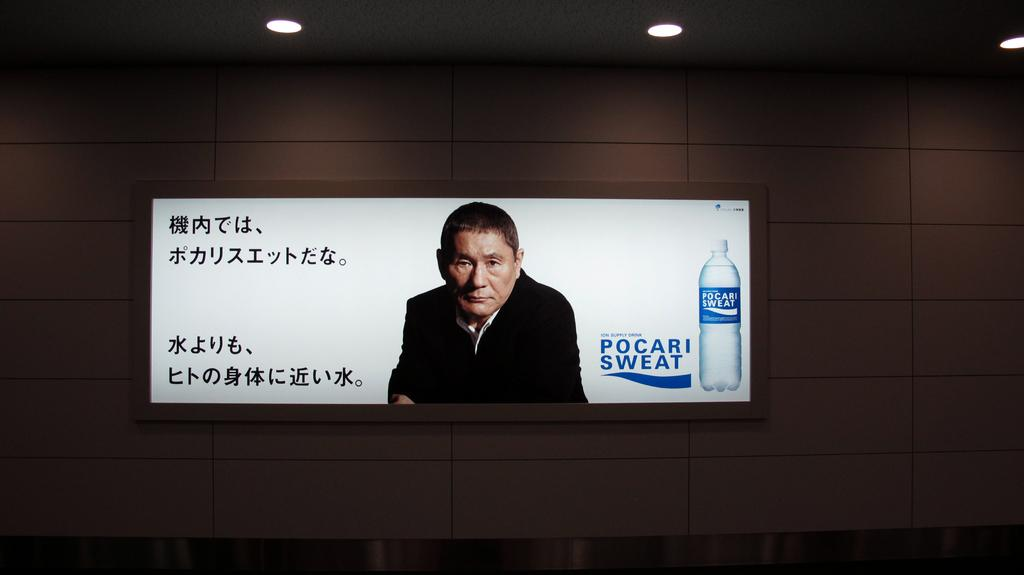What is on the wall in the image? There is a screen on the wall in the image. What can be seen on the screen? The screen displays a picture of a person and a picture of a bottle. Is there any text on the screen? Yes, there is text on the screen. What can be seen at the top of the image? There are lights visible at the top of the image. How many lizards are crawling on the screen in the image? There are no lizards present in the image; the screen displays a picture of a person and a picture of a bottle. 